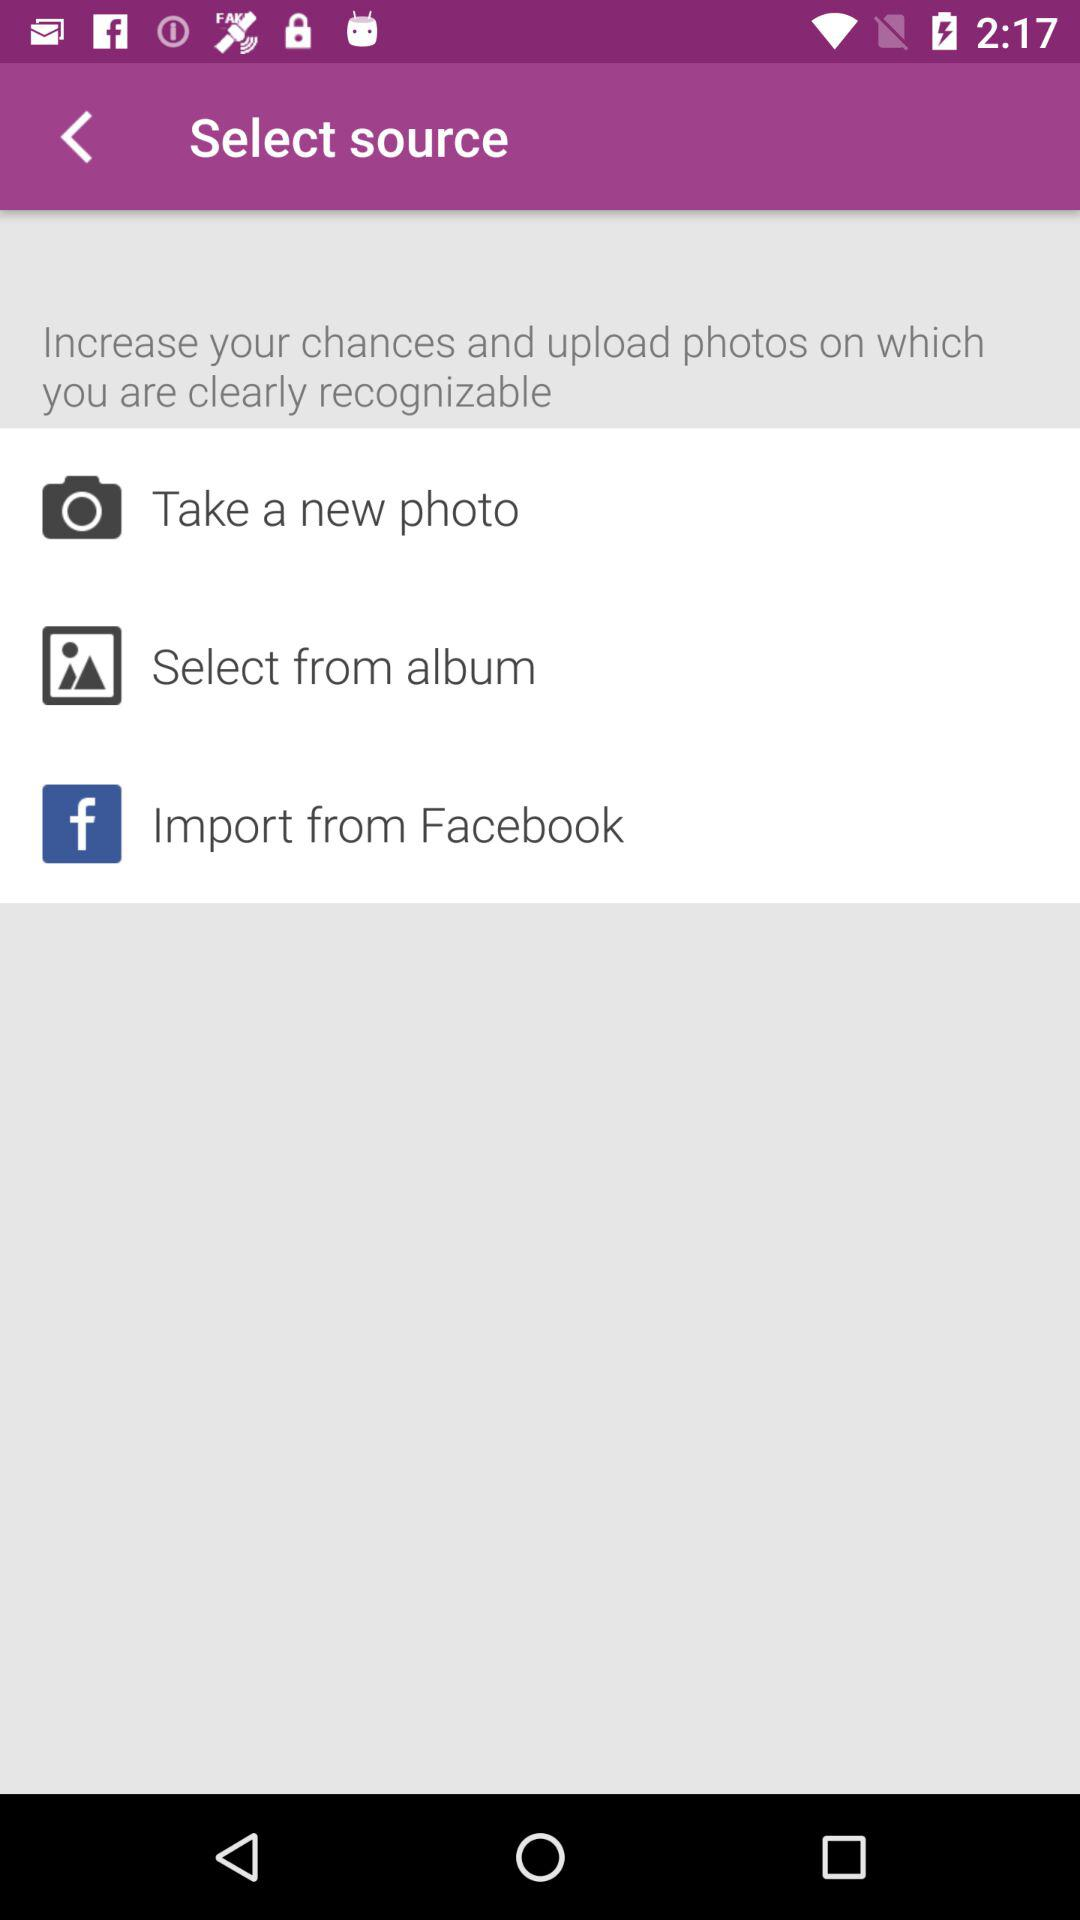How many options are there that let you upload a photo?
Answer the question using a single word or phrase. 3 